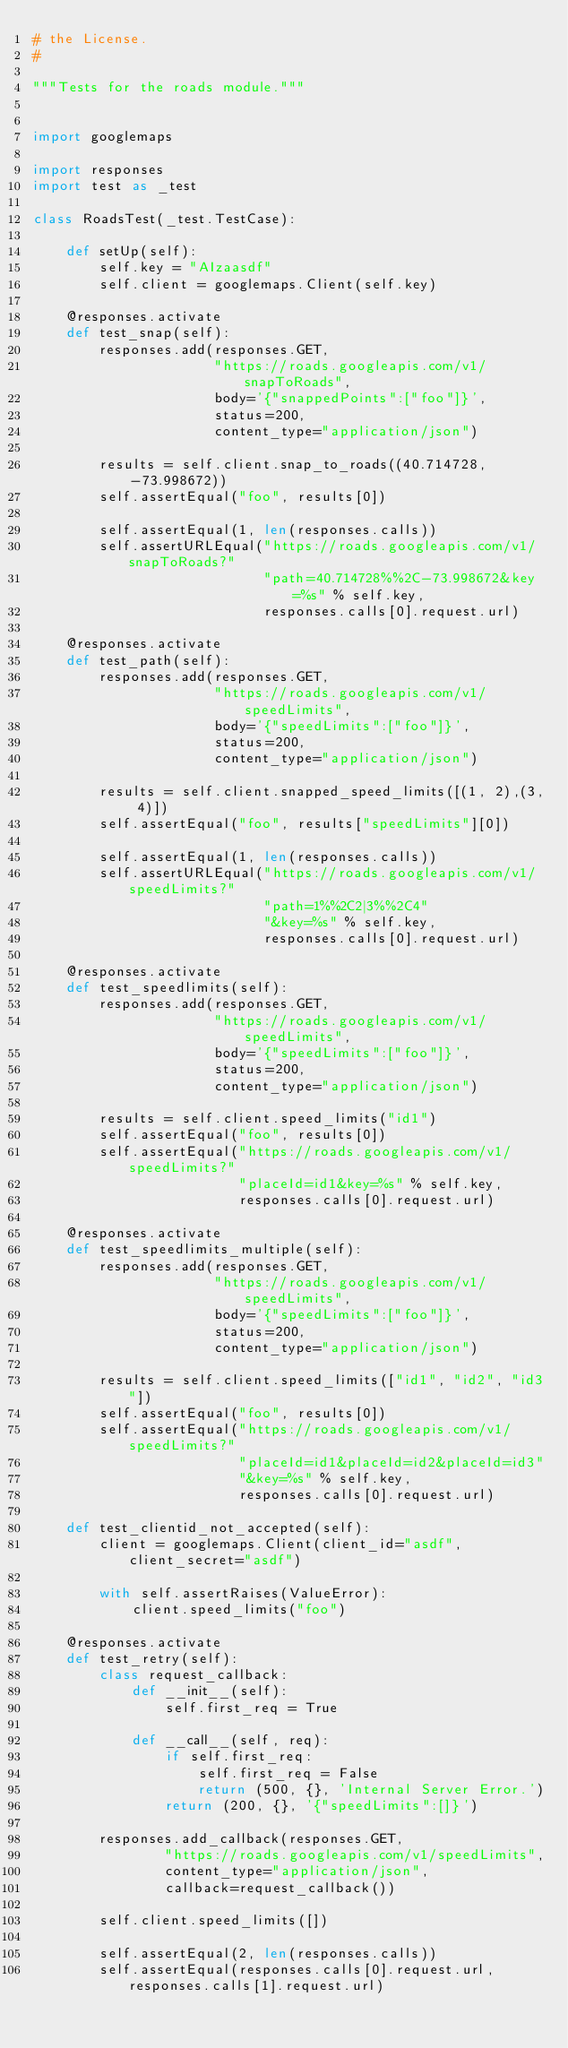Convert code to text. <code><loc_0><loc_0><loc_500><loc_500><_Python_># the License.
#

"""Tests for the roads module."""


import googlemaps

import responses
import test as _test

class RoadsTest(_test.TestCase):

    def setUp(self):
        self.key = "AIzaasdf"
        self.client = googlemaps.Client(self.key)

    @responses.activate
    def test_snap(self):
        responses.add(responses.GET,
                      "https://roads.googleapis.com/v1/snapToRoads",
                      body='{"snappedPoints":["foo"]}',
                      status=200,
                      content_type="application/json")

        results = self.client.snap_to_roads((40.714728, -73.998672))
        self.assertEqual("foo", results[0])

        self.assertEqual(1, len(responses.calls))
        self.assertURLEqual("https://roads.googleapis.com/v1/snapToRoads?"
                            "path=40.714728%%2C-73.998672&key=%s" % self.key,
                            responses.calls[0].request.url)

    @responses.activate
    def test_path(self):
        responses.add(responses.GET,
                      "https://roads.googleapis.com/v1/speedLimits",
                      body='{"speedLimits":["foo"]}',
                      status=200,
                      content_type="application/json")

        results = self.client.snapped_speed_limits([(1, 2),(3, 4)])
        self.assertEqual("foo", results["speedLimits"][0])

        self.assertEqual(1, len(responses.calls))
        self.assertURLEqual("https://roads.googleapis.com/v1/speedLimits?"
                            "path=1%%2C2|3%%2C4"
                            "&key=%s" % self.key,
                            responses.calls[0].request.url)

    @responses.activate
    def test_speedlimits(self):
        responses.add(responses.GET,
                      "https://roads.googleapis.com/v1/speedLimits",
                      body='{"speedLimits":["foo"]}',
                      status=200,
                      content_type="application/json")

        results = self.client.speed_limits("id1")
        self.assertEqual("foo", results[0])
        self.assertEqual("https://roads.googleapis.com/v1/speedLimits?"
                         "placeId=id1&key=%s" % self.key,
                         responses.calls[0].request.url)

    @responses.activate
    def test_speedlimits_multiple(self):
        responses.add(responses.GET,
                      "https://roads.googleapis.com/v1/speedLimits",
                      body='{"speedLimits":["foo"]}',
                      status=200,
                      content_type="application/json")

        results = self.client.speed_limits(["id1", "id2", "id3"])
        self.assertEqual("foo", results[0])
        self.assertEqual("https://roads.googleapis.com/v1/speedLimits?"
                         "placeId=id1&placeId=id2&placeId=id3"
                         "&key=%s" % self.key,
                         responses.calls[0].request.url)

    def test_clientid_not_accepted(self):
        client = googlemaps.Client(client_id="asdf", client_secret="asdf")

        with self.assertRaises(ValueError):
            client.speed_limits("foo")

    @responses.activate
    def test_retry(self):
        class request_callback:
            def __init__(self):
                self.first_req = True

            def __call__(self, req):
                if self.first_req:
                    self.first_req = False
                    return (500, {}, 'Internal Server Error.')
                return (200, {}, '{"speedLimits":[]}')

        responses.add_callback(responses.GET,
                "https://roads.googleapis.com/v1/speedLimits",
                content_type="application/json",
                callback=request_callback())

        self.client.speed_limits([])

        self.assertEqual(2, len(responses.calls))
        self.assertEqual(responses.calls[0].request.url, responses.calls[1].request.url)
</code> 